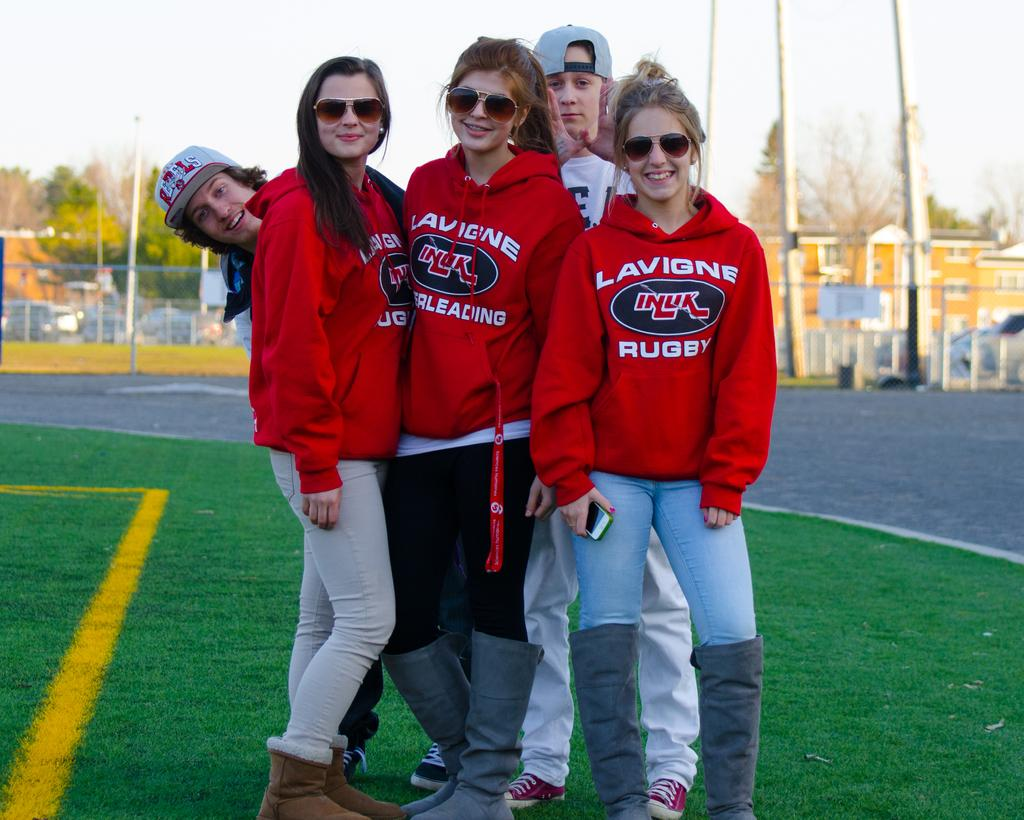<image>
Relay a brief, clear account of the picture shown. Three women in red Lavigne sweatshirts stand on a lawn together. 